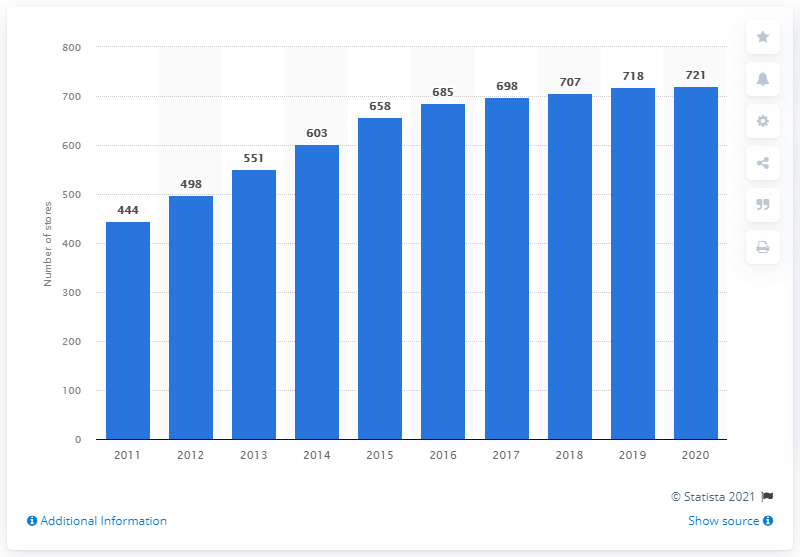Outline some significant characteristics in this image. In 2020, Zumiez operated a total of 721 stores. 